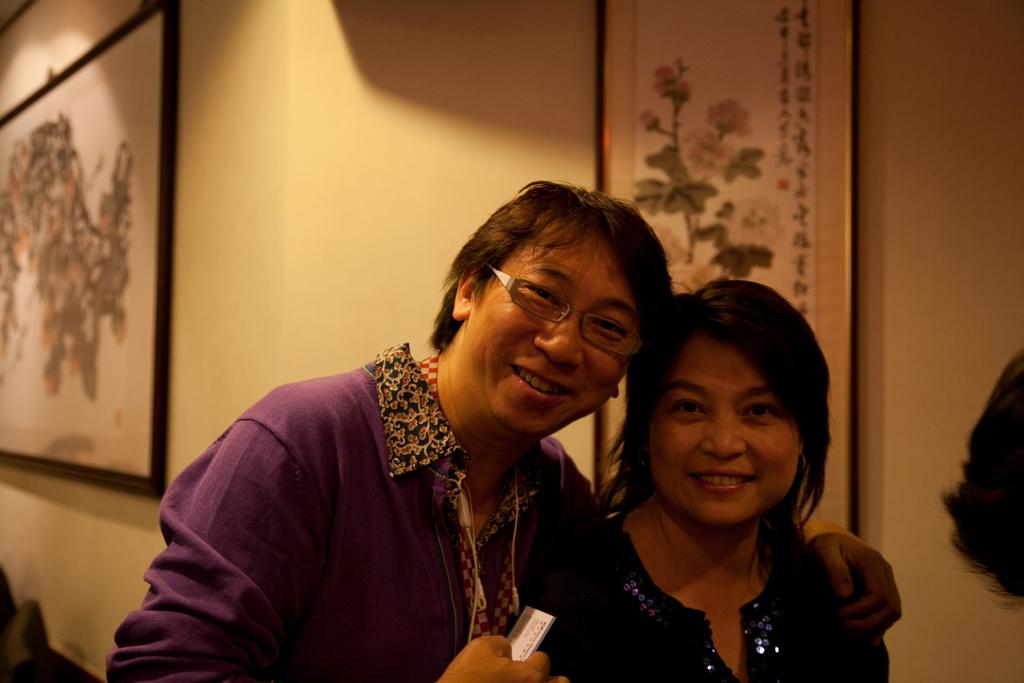How many people are in the image? There are two persons in the image. What are the persons wearing? The persons are wearing clothes. What can be seen in the background of the image? There are wall hangings in the background of the image. What type of curtain can be seen in the image? There is no curtain present in the image. What type of field is visible in the background of the image? There is no field visible in the image; it features two persons and wall hangings in the background. 